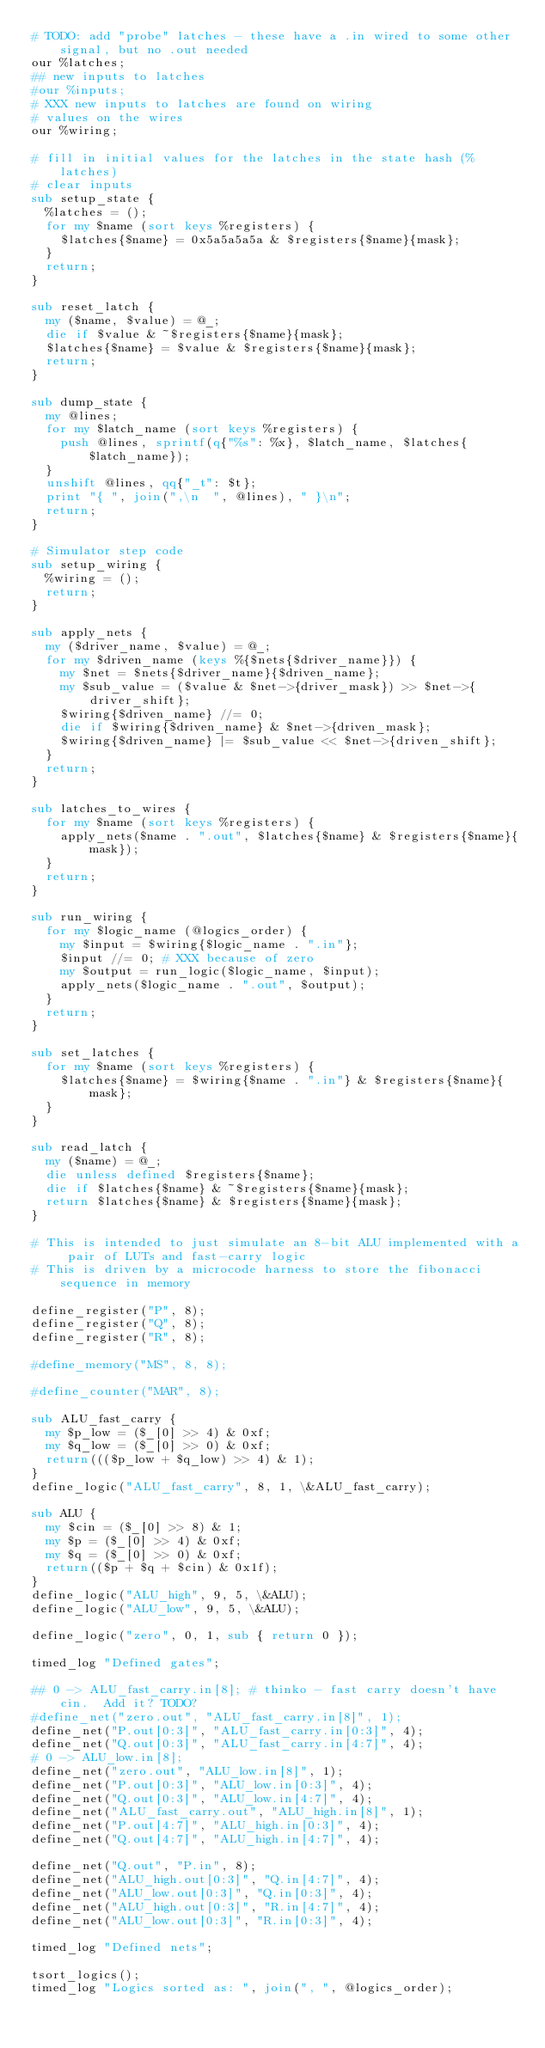Convert code to text. <code><loc_0><loc_0><loc_500><loc_500><_Perl_># TODO: add "probe" latches - these have a .in wired to some other signal, but no .out needed
our %latches;
## new inputs to latches
#our %inputs;
# XXX new inputs to latches are found on wiring
# values on the wires
our %wiring;

# fill in initial values for the latches in the state hash (%latches)
# clear inputs
sub setup_state {
  %latches = ();
  for my $name (sort keys %registers) {
    $latches{$name} = 0x5a5a5a5a & $registers{$name}{mask};
  }
  return;
}

sub reset_latch {
  my ($name, $value) = @_;
  die if $value & ~$registers{$name}{mask};
  $latches{$name} = $value & $registers{$name}{mask};
  return;
}

sub dump_state {
  my @lines;
  for my $latch_name (sort keys %registers) {
    push @lines, sprintf(q{"%s": %x}, $latch_name, $latches{$latch_name});
  }
  unshift @lines, qq{"_t": $t};
  print "{ ", join(",\n  ", @lines), " }\n";
  return;
}

# Simulator step code
sub setup_wiring {
  %wiring = ();
  return;
}

sub apply_nets {
  my ($driver_name, $value) = @_;
  for my $driven_name (keys %{$nets{$driver_name}}) {
    my $net = $nets{$driver_name}{$driven_name};
    my $sub_value = ($value & $net->{driver_mask}) >> $net->{driver_shift};
    $wiring{$driven_name} //= 0;
    die if $wiring{$driven_name} & $net->{driven_mask};
    $wiring{$driven_name} |= $sub_value << $net->{driven_shift};
  }
  return;
}

sub latches_to_wires {
  for my $name (sort keys %registers) {
    apply_nets($name . ".out", $latches{$name} & $registers{$name}{mask});
  }
  return;
}

sub run_wiring {
  for my $logic_name (@logics_order) {
    my $input = $wiring{$logic_name . ".in"};
    $input //= 0; # XXX because of zero
    my $output = run_logic($logic_name, $input);
    apply_nets($logic_name . ".out", $output);
  }
  return;
}

sub set_latches {
  for my $name (sort keys %registers) {
    $latches{$name} = $wiring{$name . ".in"} & $registers{$name}{mask};
  }
}

sub read_latch {
  my ($name) = @_;
  die unless defined $registers{$name};
  die if $latches{$name} & ~$registers{$name}{mask};
  return $latches{$name} & $registers{$name}{mask};
}

# This is intended to just simulate an 8-bit ALU implemented with a pair of LUTs and fast-carry logic
# This is driven by a microcode harness to store the fibonacci sequence in memory

define_register("P", 8);
define_register("Q", 8);
define_register("R", 8);

#define_memory("MS", 8, 8);

#define_counter("MAR", 8);

sub ALU_fast_carry {
  my $p_low = ($_[0] >> 4) & 0xf;
  my $q_low = ($_[0] >> 0) & 0xf;
  return((($p_low + $q_low) >> 4) & 1);
}
define_logic("ALU_fast_carry", 8, 1, \&ALU_fast_carry);

sub ALU {
  my $cin = ($_[0] >> 8) & 1;
  my $p = ($_[0] >> 4) & 0xf;
  my $q = ($_[0] >> 0) & 0xf;
  return(($p + $q + $cin) & 0x1f);
}
define_logic("ALU_high", 9, 5, \&ALU);
define_logic("ALU_low", 9, 5, \&ALU);

define_logic("zero", 0, 1, sub { return 0 });

timed_log "Defined gates";

## 0 -> ALU_fast_carry.in[8]; # thinko - fast carry doesn't have cin.  Add it? TODO?
#define_net("zero.out", "ALU_fast_carry.in[8]", 1);
define_net("P.out[0:3]", "ALU_fast_carry.in[0:3]", 4);
define_net("Q.out[0:3]", "ALU_fast_carry.in[4:7]", 4);
# 0 -> ALU_low.in[8];
define_net("zero.out", "ALU_low.in[8]", 1);
define_net("P.out[0:3]", "ALU_low.in[0:3]", 4);
define_net("Q.out[0:3]", "ALU_low.in[4:7]", 4);
define_net("ALU_fast_carry.out", "ALU_high.in[8]", 1);
define_net("P.out[4:7]", "ALU_high.in[0:3]", 4);
define_net("Q.out[4:7]", "ALU_high.in[4:7]", 4);

define_net("Q.out", "P.in", 8);
define_net("ALU_high.out[0:3]", "Q.in[4:7]", 4);
define_net("ALU_low.out[0:3]", "Q.in[0:3]", 4);
define_net("ALU_high.out[0:3]", "R.in[4:7]", 4);
define_net("ALU_low.out[0:3]", "R.in[0:3]", 4);

timed_log "Defined nets";

tsort_logics();
timed_log "Logics sorted as: ", join(", ", @logics_order);
</code> 